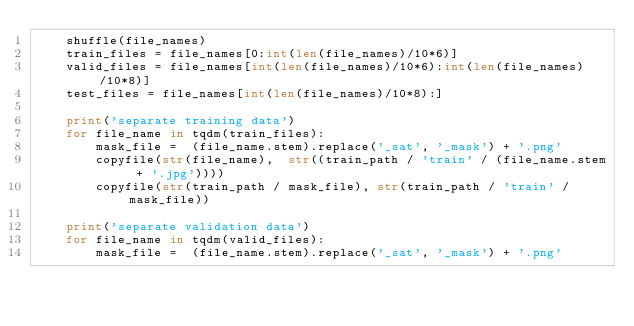<code> <loc_0><loc_0><loc_500><loc_500><_Python_>    shuffle(file_names)
    train_files = file_names[0:int(len(file_names)/10*6)]
    valid_files = file_names[int(len(file_names)/10*6):int(len(file_names)/10*8)]
    test_files = file_names[int(len(file_names)/10*8):]
    
    print('separate training data')
    for file_name in tqdm(train_files):
        mask_file =  (file_name.stem).replace('_sat', '_mask') + '.png'
        copyfile(str(file_name),  str((train_path / 'train' / (file_name.stem + '.jpg'))))
        copyfile(str(train_path / mask_file), str(train_path / 'train' / mask_file))

    print('separate validation data')
    for file_name in tqdm(valid_files):
        mask_file =  (file_name.stem).replace('_sat', '_mask') + '.png'</code> 